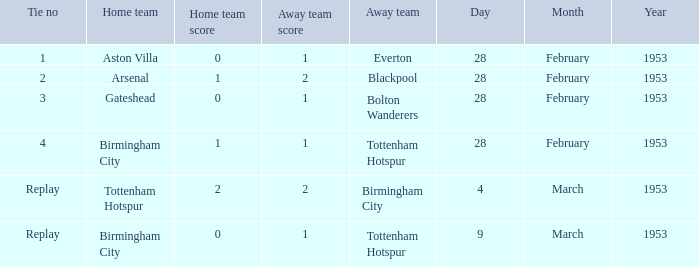Which Score has a Date of 28 february 1953, and a Tie no of 3? 0–1. 